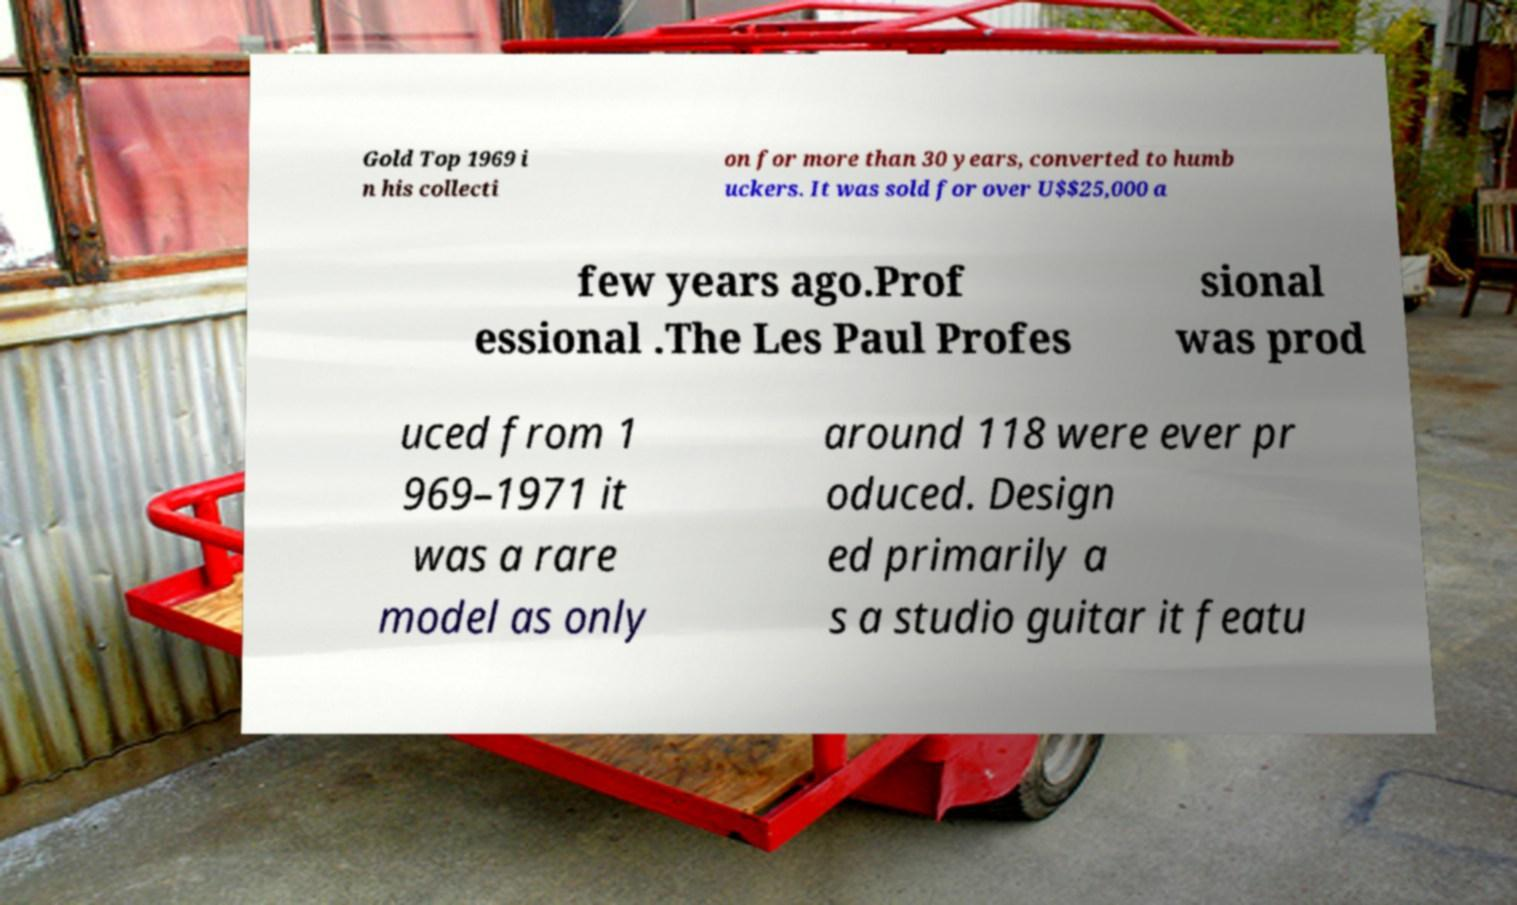Can you read and provide the text displayed in the image?This photo seems to have some interesting text. Can you extract and type it out for me? Gold Top 1969 i n his collecti on for more than 30 years, converted to humb uckers. It was sold for over U$$25,000 a few years ago.Prof essional .The Les Paul Profes sional was prod uced from 1 969–1971 it was a rare model as only around 118 were ever pr oduced. Design ed primarily a s a studio guitar it featu 